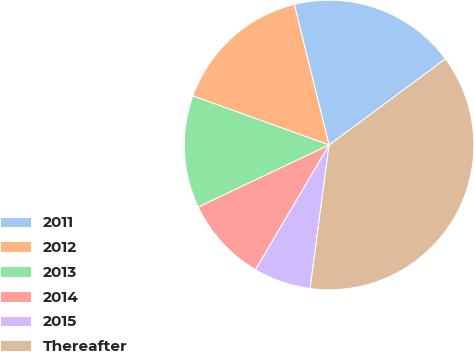<chart> <loc_0><loc_0><loc_500><loc_500><pie_chart><fcel>2011<fcel>2012<fcel>2013<fcel>2014<fcel>2015<fcel>Thereafter<nl><fcel>18.72%<fcel>15.64%<fcel>12.55%<fcel>9.47%<fcel>6.39%<fcel>37.23%<nl></chart> 